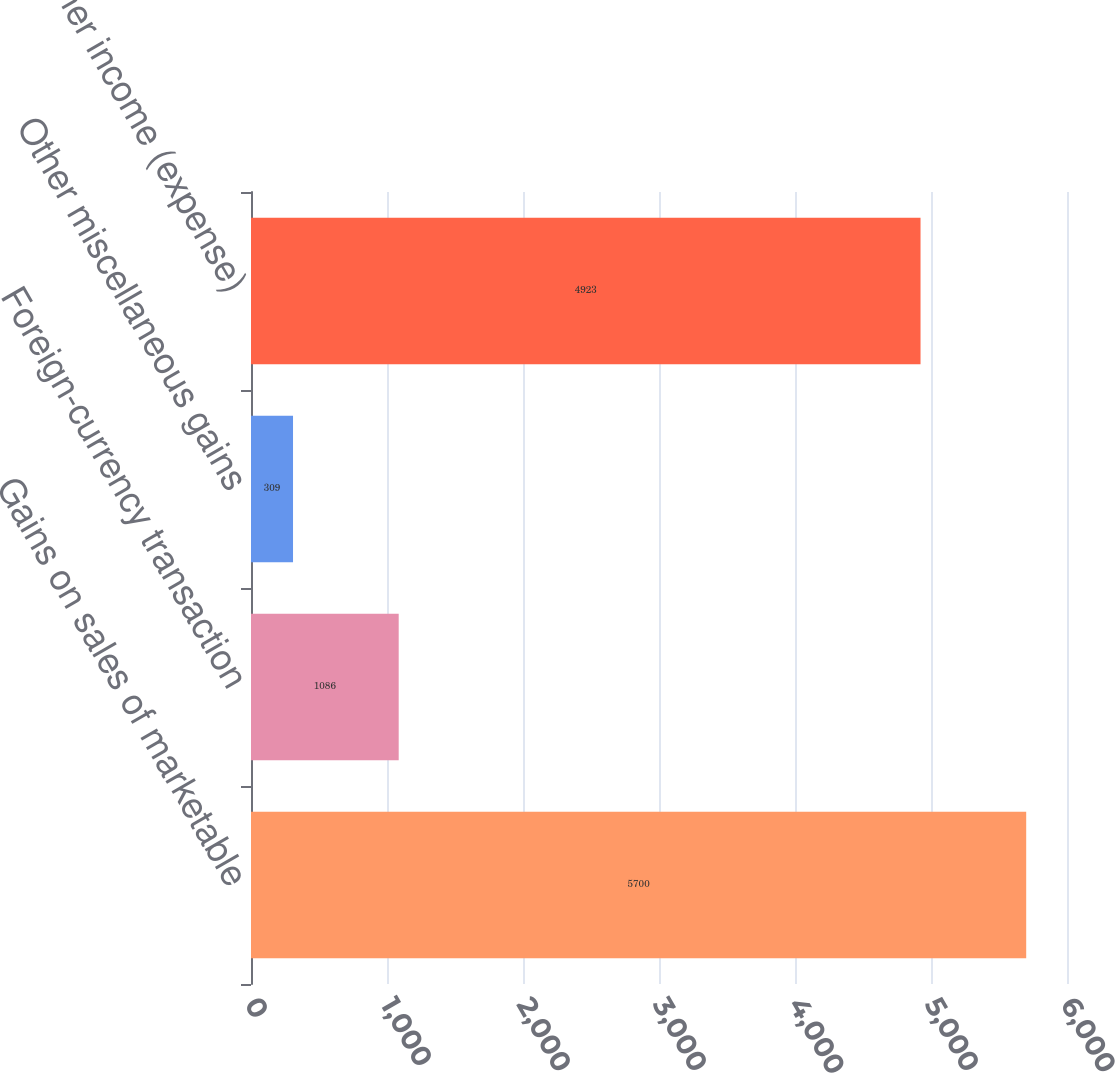Convert chart. <chart><loc_0><loc_0><loc_500><loc_500><bar_chart><fcel>Gains on sales of marketable<fcel>Foreign-currency transaction<fcel>Other miscellaneous gains<fcel>Total other income (expense)<nl><fcel>5700<fcel>1086<fcel>309<fcel>4923<nl></chart> 